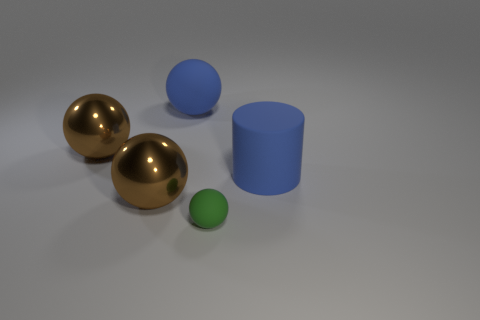How many objects are there in the image? There are four objects in the image: two larger spheres with a reflective surface, one smaller green sphere with a matte finish, and a blue cylinder. 